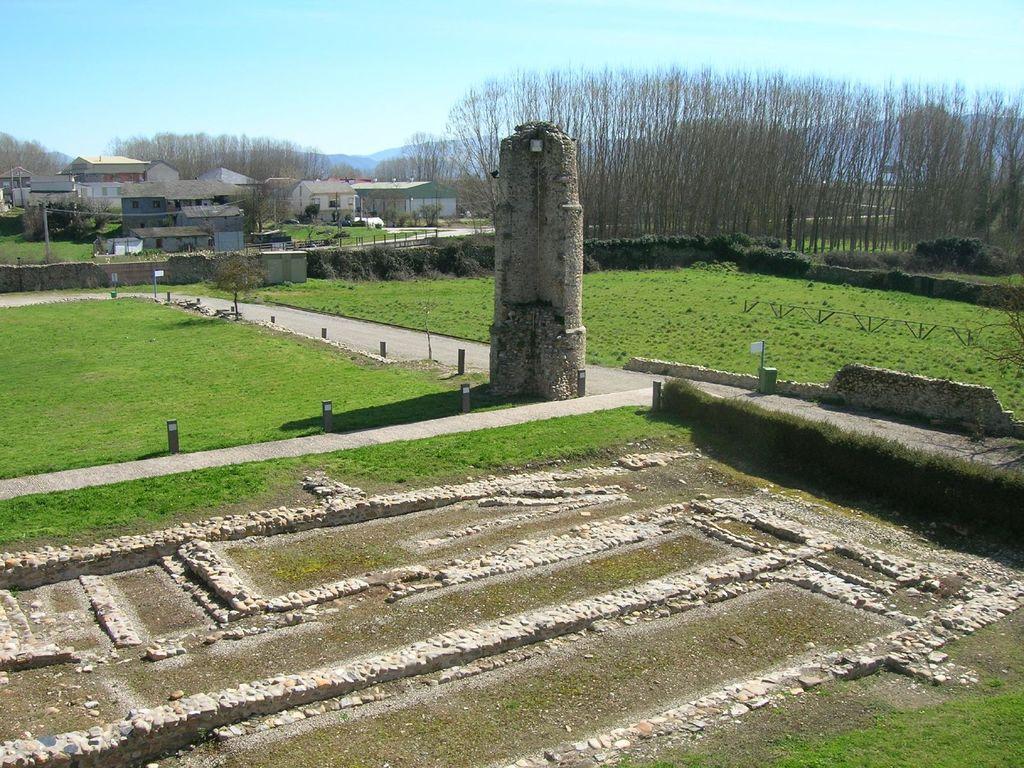How would you summarize this image in a sentence or two? In this image at the bottom there is grass and some small stones and a walkway, in the center there is a pillar and in the background there are some houses, trees and mountains and also there are some poles. At the top of the image there is sky. 